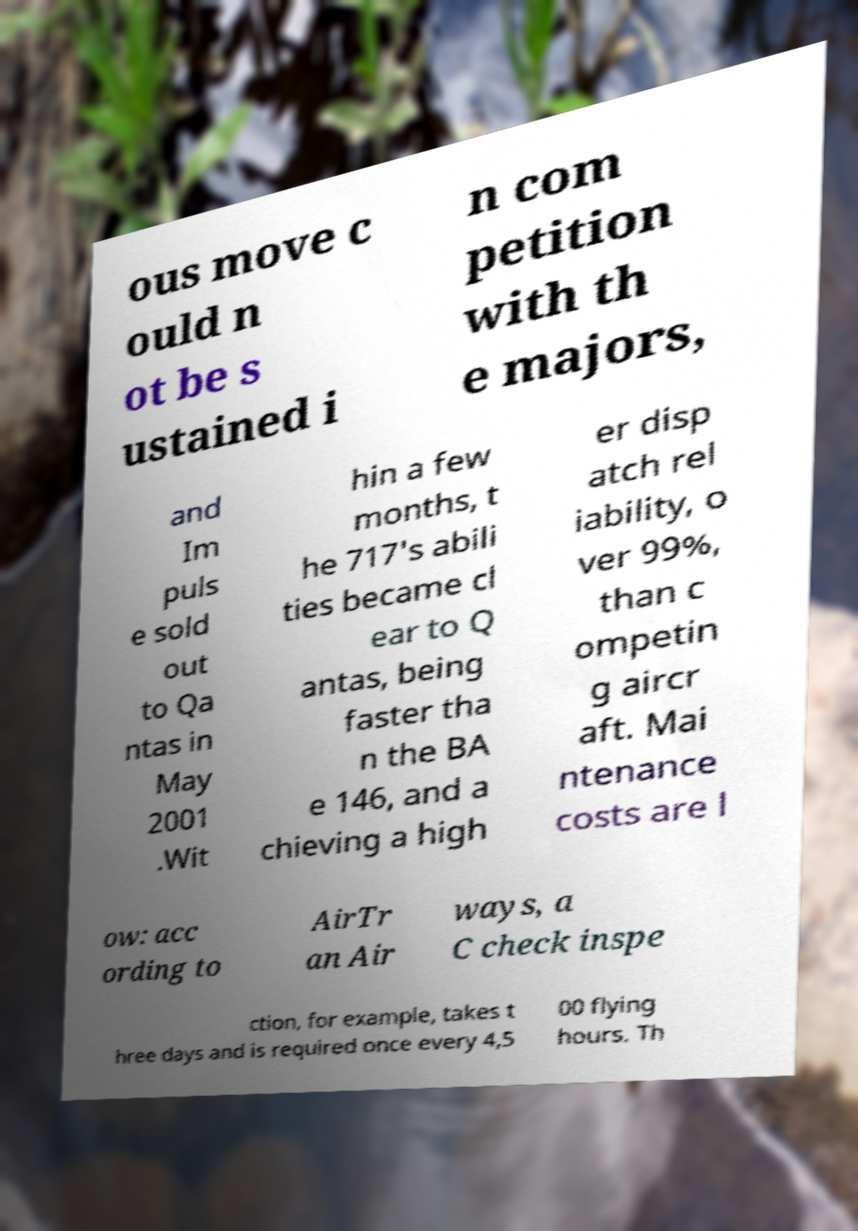Could you extract and type out the text from this image? ous move c ould n ot be s ustained i n com petition with th e majors, and Im puls e sold out to Qa ntas in May 2001 .Wit hin a few months, t he 717's abili ties became cl ear to Q antas, being faster tha n the BA e 146, and a chieving a high er disp atch rel iability, o ver 99%, than c ompetin g aircr aft. Mai ntenance costs are l ow: acc ording to AirTr an Air ways, a C check inspe ction, for example, takes t hree days and is required once every 4,5 00 flying hours. Th 